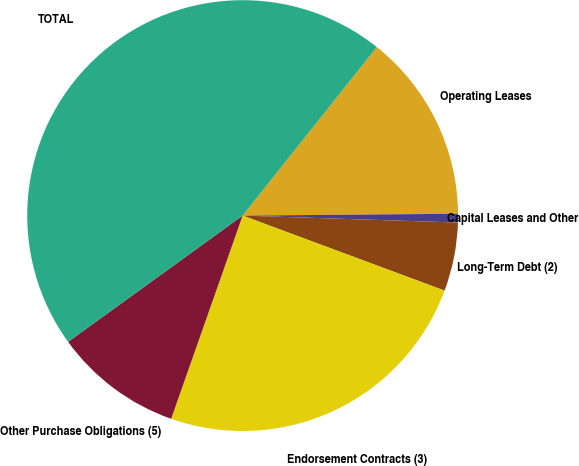Convert chart to OTSL. <chart><loc_0><loc_0><loc_500><loc_500><pie_chart><fcel>Operating Leases<fcel>Capital Leases and Other<fcel>Long-Term Debt (2)<fcel>Endorsement Contracts (3)<fcel>Other Purchase Obligations (5)<fcel>TOTAL<nl><fcel>14.16%<fcel>0.65%<fcel>5.15%<fcel>24.72%<fcel>9.65%<fcel>45.67%<nl></chart> 